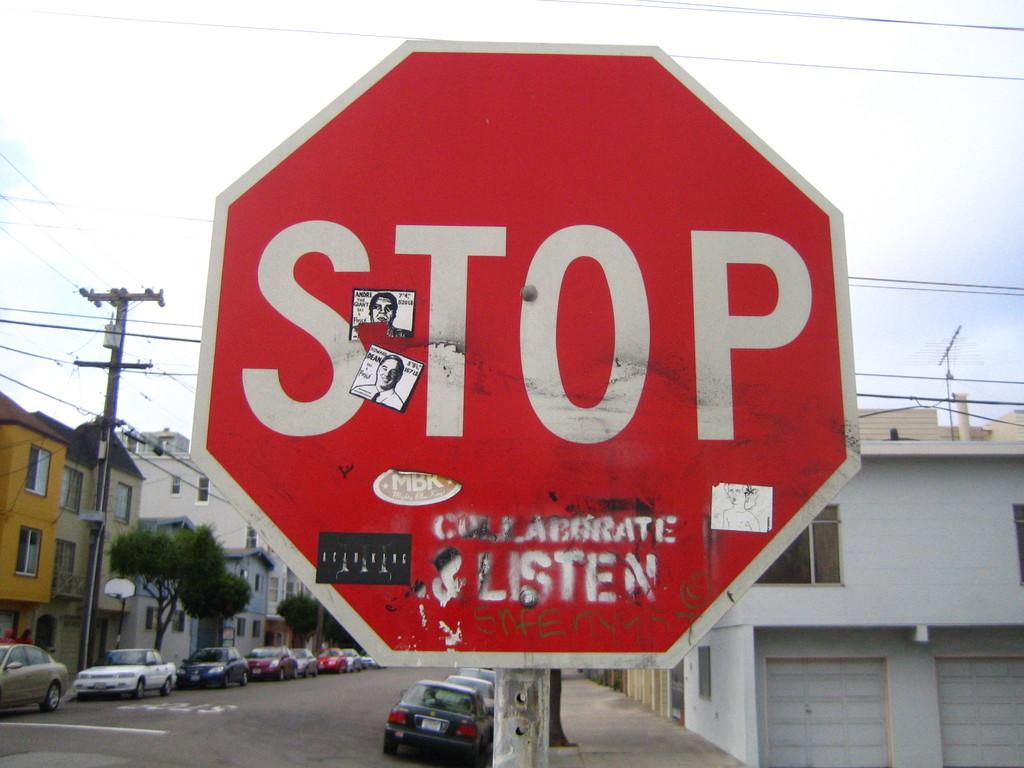<image>
Write a terse but informative summary of the picture. A stop sign with a lot of stickers on it 